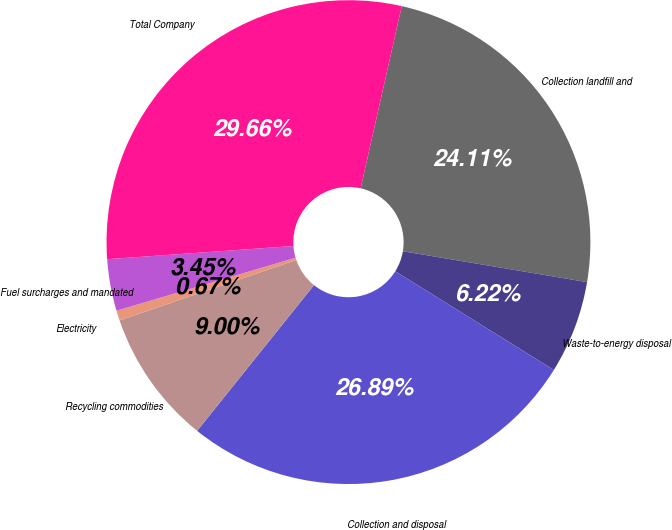<chart> <loc_0><loc_0><loc_500><loc_500><pie_chart><fcel>Collection landfill and<fcel>Waste-to-energy disposal<fcel>Collection and disposal<fcel>Recycling commodities<fcel>Electricity<fcel>Fuel surcharges and mandated<fcel>Total Company<nl><fcel>24.11%<fcel>6.22%<fcel>26.89%<fcel>9.0%<fcel>0.67%<fcel>3.45%<fcel>29.66%<nl></chart> 